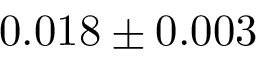Convert formula to latex. <formula><loc_0><loc_0><loc_500><loc_500>0 . 0 1 8 \pm 0 . 0 0 3</formula> 